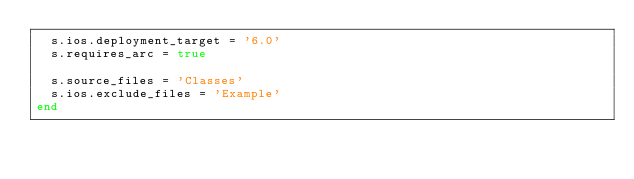Convert code to text. <code><loc_0><loc_0><loc_500><loc_500><_Ruby_>  s.ios.deployment_target = '6.0'
  s.requires_arc = true

  s.source_files = 'Classes'
  s.ios.exclude_files = 'Example'
end
</code> 